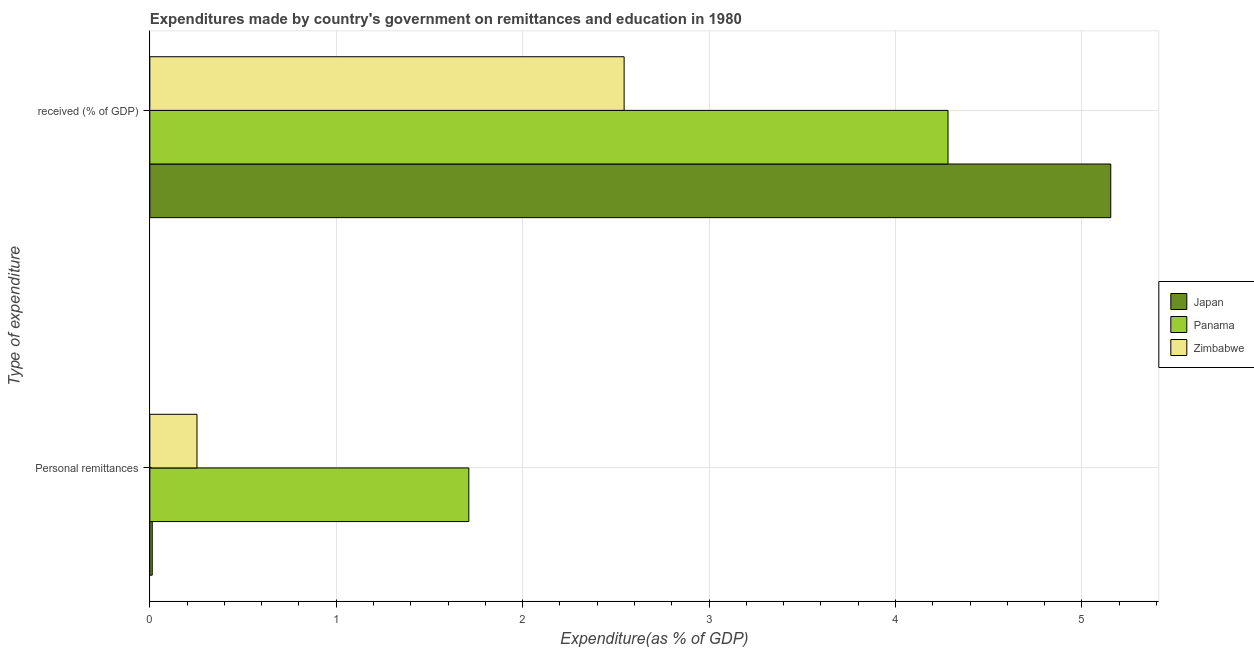How many groups of bars are there?
Provide a succinct answer. 2. Are the number of bars per tick equal to the number of legend labels?
Offer a terse response. Yes. How many bars are there on the 1st tick from the top?
Keep it short and to the point. 3. How many bars are there on the 2nd tick from the bottom?
Offer a terse response. 3. What is the label of the 1st group of bars from the top?
Make the answer very short.  received (% of GDP). What is the expenditure in personal remittances in Zimbabwe?
Your response must be concise. 0.25. Across all countries, what is the maximum expenditure in education?
Your response must be concise. 5.15. Across all countries, what is the minimum expenditure in personal remittances?
Make the answer very short. 0.01. In which country was the expenditure in education maximum?
Offer a very short reply. Japan. In which country was the expenditure in education minimum?
Offer a very short reply. Zimbabwe. What is the total expenditure in personal remittances in the graph?
Give a very brief answer. 1.98. What is the difference between the expenditure in education in Panama and that in Zimbabwe?
Offer a terse response. 1.74. What is the difference between the expenditure in personal remittances in Japan and the expenditure in education in Panama?
Make the answer very short. -4.27. What is the average expenditure in personal remittances per country?
Offer a terse response. 0.66. What is the difference between the expenditure in personal remittances and expenditure in education in Zimbabwe?
Your answer should be compact. -2.29. In how many countries, is the expenditure in education greater than 1.8 %?
Make the answer very short. 3. What is the ratio of the expenditure in education in Japan to that in Zimbabwe?
Give a very brief answer. 2.03. Is the expenditure in education in Panama less than that in Zimbabwe?
Provide a short and direct response. No. In how many countries, is the expenditure in education greater than the average expenditure in education taken over all countries?
Your answer should be very brief. 2. What does the 2nd bar from the top in  received (% of GDP) represents?
Ensure brevity in your answer.  Panama. What does the 2nd bar from the bottom in  received (% of GDP) represents?
Your response must be concise. Panama. How many bars are there?
Provide a short and direct response. 6. Are all the bars in the graph horizontal?
Offer a terse response. Yes. What is the difference between two consecutive major ticks on the X-axis?
Ensure brevity in your answer.  1. Does the graph contain any zero values?
Provide a short and direct response. No. Where does the legend appear in the graph?
Provide a succinct answer. Center right. What is the title of the graph?
Your answer should be compact. Expenditures made by country's government on remittances and education in 1980. What is the label or title of the X-axis?
Your answer should be very brief. Expenditure(as % of GDP). What is the label or title of the Y-axis?
Ensure brevity in your answer.  Type of expenditure. What is the Expenditure(as % of GDP) in Japan in Personal remittances?
Your response must be concise. 0.01. What is the Expenditure(as % of GDP) of Panama in Personal remittances?
Your answer should be very brief. 1.71. What is the Expenditure(as % of GDP) of Zimbabwe in Personal remittances?
Offer a very short reply. 0.25. What is the Expenditure(as % of GDP) in Japan in  received (% of GDP)?
Offer a terse response. 5.15. What is the Expenditure(as % of GDP) of Panama in  received (% of GDP)?
Offer a very short reply. 4.28. What is the Expenditure(as % of GDP) in Zimbabwe in  received (% of GDP)?
Keep it short and to the point. 2.54. Across all Type of expenditure, what is the maximum Expenditure(as % of GDP) of Japan?
Your answer should be very brief. 5.15. Across all Type of expenditure, what is the maximum Expenditure(as % of GDP) in Panama?
Ensure brevity in your answer.  4.28. Across all Type of expenditure, what is the maximum Expenditure(as % of GDP) in Zimbabwe?
Make the answer very short. 2.54. Across all Type of expenditure, what is the minimum Expenditure(as % of GDP) of Japan?
Provide a short and direct response. 0.01. Across all Type of expenditure, what is the minimum Expenditure(as % of GDP) in Panama?
Provide a short and direct response. 1.71. Across all Type of expenditure, what is the minimum Expenditure(as % of GDP) of Zimbabwe?
Ensure brevity in your answer.  0.25. What is the total Expenditure(as % of GDP) in Japan in the graph?
Offer a terse response. 5.17. What is the total Expenditure(as % of GDP) in Panama in the graph?
Give a very brief answer. 5.99. What is the total Expenditure(as % of GDP) of Zimbabwe in the graph?
Keep it short and to the point. 2.8. What is the difference between the Expenditure(as % of GDP) in Japan in Personal remittances and that in  received (% of GDP)?
Offer a very short reply. -5.14. What is the difference between the Expenditure(as % of GDP) of Panama in Personal remittances and that in  received (% of GDP)?
Ensure brevity in your answer.  -2.57. What is the difference between the Expenditure(as % of GDP) of Zimbabwe in Personal remittances and that in  received (% of GDP)?
Your answer should be compact. -2.29. What is the difference between the Expenditure(as % of GDP) in Japan in Personal remittances and the Expenditure(as % of GDP) in Panama in  received (% of GDP)?
Your answer should be very brief. -4.27. What is the difference between the Expenditure(as % of GDP) in Japan in Personal remittances and the Expenditure(as % of GDP) in Zimbabwe in  received (% of GDP)?
Provide a short and direct response. -2.53. What is the difference between the Expenditure(as % of GDP) in Panama in Personal remittances and the Expenditure(as % of GDP) in Zimbabwe in  received (% of GDP)?
Make the answer very short. -0.83. What is the average Expenditure(as % of GDP) of Japan per Type of expenditure?
Your answer should be compact. 2.58. What is the average Expenditure(as % of GDP) of Panama per Type of expenditure?
Give a very brief answer. 3. What is the average Expenditure(as % of GDP) in Zimbabwe per Type of expenditure?
Your answer should be very brief. 1.4. What is the difference between the Expenditure(as % of GDP) in Japan and Expenditure(as % of GDP) in Panama in Personal remittances?
Offer a very short reply. -1.7. What is the difference between the Expenditure(as % of GDP) in Japan and Expenditure(as % of GDP) in Zimbabwe in Personal remittances?
Give a very brief answer. -0.24. What is the difference between the Expenditure(as % of GDP) in Panama and Expenditure(as % of GDP) in Zimbabwe in Personal remittances?
Make the answer very short. 1.46. What is the difference between the Expenditure(as % of GDP) in Japan and Expenditure(as % of GDP) in Panama in  received (% of GDP)?
Your answer should be very brief. 0.87. What is the difference between the Expenditure(as % of GDP) in Japan and Expenditure(as % of GDP) in Zimbabwe in  received (% of GDP)?
Your answer should be compact. 2.61. What is the difference between the Expenditure(as % of GDP) in Panama and Expenditure(as % of GDP) in Zimbabwe in  received (% of GDP)?
Ensure brevity in your answer.  1.74. What is the ratio of the Expenditure(as % of GDP) in Japan in Personal remittances to that in  received (% of GDP)?
Your answer should be compact. 0. What is the ratio of the Expenditure(as % of GDP) of Panama in Personal remittances to that in  received (% of GDP)?
Give a very brief answer. 0.4. What is the ratio of the Expenditure(as % of GDP) of Zimbabwe in Personal remittances to that in  received (% of GDP)?
Keep it short and to the point. 0.1. What is the difference between the highest and the second highest Expenditure(as % of GDP) of Japan?
Give a very brief answer. 5.14. What is the difference between the highest and the second highest Expenditure(as % of GDP) of Panama?
Offer a terse response. 2.57. What is the difference between the highest and the second highest Expenditure(as % of GDP) in Zimbabwe?
Your answer should be very brief. 2.29. What is the difference between the highest and the lowest Expenditure(as % of GDP) in Japan?
Make the answer very short. 5.14. What is the difference between the highest and the lowest Expenditure(as % of GDP) in Panama?
Provide a short and direct response. 2.57. What is the difference between the highest and the lowest Expenditure(as % of GDP) of Zimbabwe?
Your response must be concise. 2.29. 